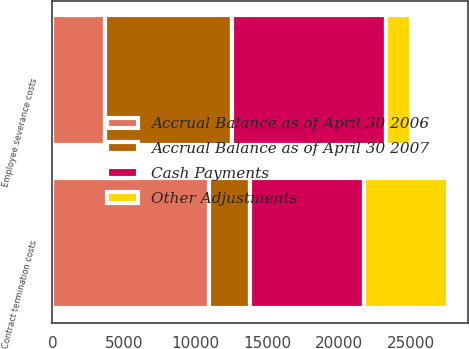Convert chart. <chart><loc_0><loc_0><loc_500><loc_500><stacked_bar_chart><ecel><fcel>Employee severance costs<fcel>Contract termination costs<nl><fcel>Other Adjustments<fcel>1737<fcel>5821<nl><fcel>Accrual Balance as of April 30 2007<fcel>8817<fcel>2874<nl><fcel>Cash Payments<fcel>10768<fcel>7972<nl><fcel>Accrual Balance as of April 30 2006<fcel>3688<fcel>10919<nl></chart> 